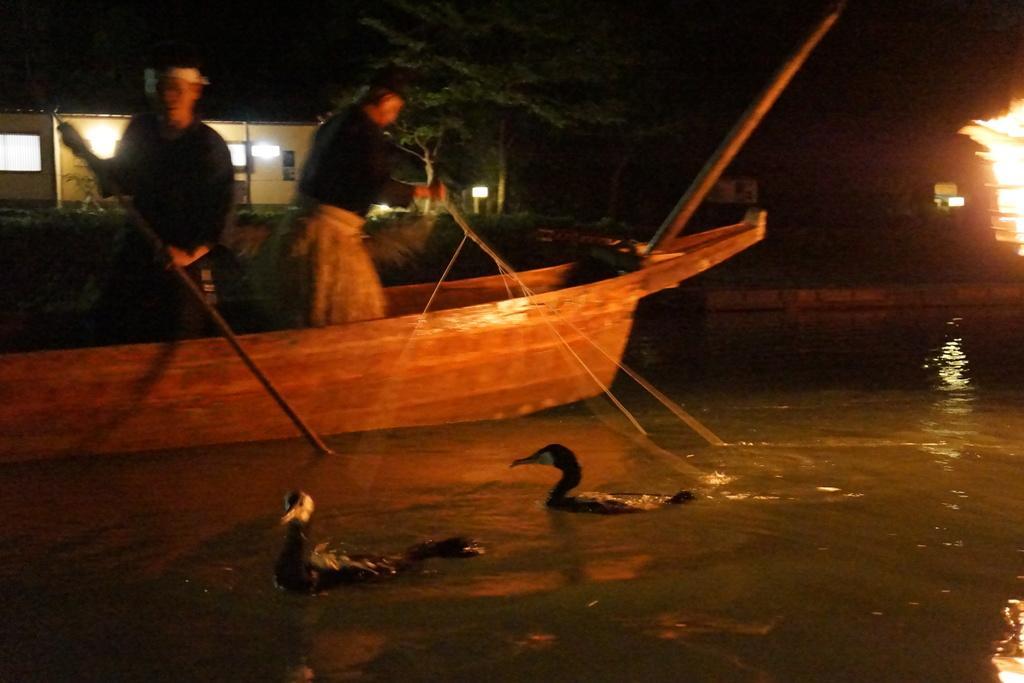In one or two sentences, can you explain what this image depicts? This image is clicked outside. There are trees at the top. There is something like building on the left side. There is a boat in the middle. In that there are two persons standing. There is water at the bottom. In that there are ducks. There is light on the right side. 